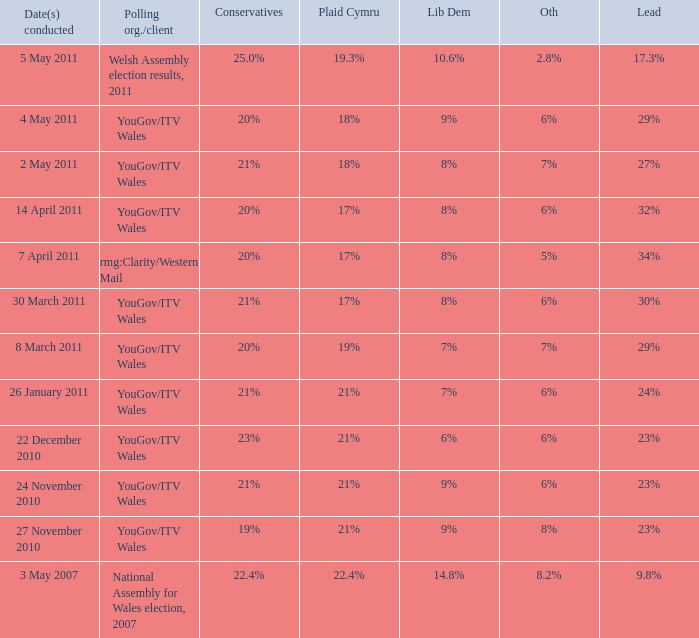I want the lead for others being 5% 34%. 